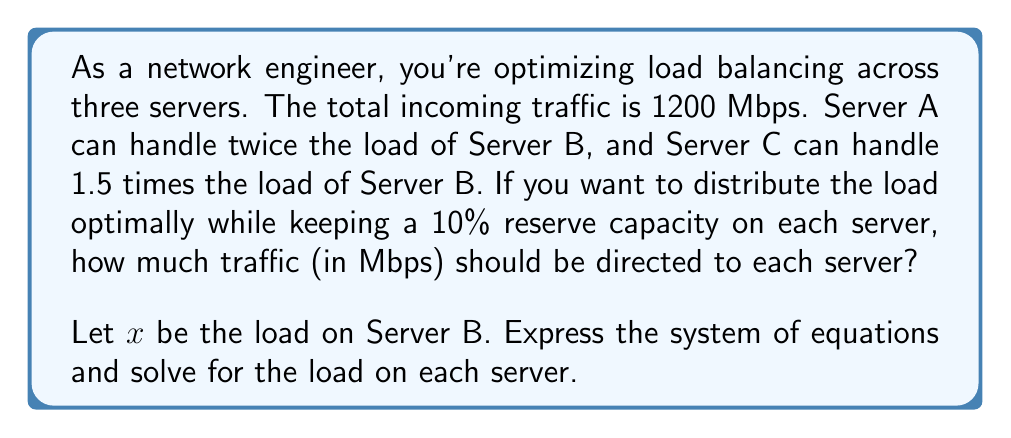Can you solve this math problem? Let's approach this step-by-step:

1) Let $x$ be the load on Server B. Then:
   - Load on Server A = $2x$
   - Load on Server C = $1.5x$

2) The total traffic is 1200 Mbps, so we can write our first equation:
   $$ x + 2x + 1.5x = 1200 $$

3) Simplify:
   $$ 4.5x = 1200 $$

4) Solve for $x$:
   $$ x = \frac{1200}{4.5} = 266.67 $$

5) Now, we know:
   - Server B load: $266.67$ Mbps
   - Server A load: $2 * 266.67 = 533.33$ Mbps
   - Server C load: $1.5 * 266.67 = 400$ Mbps

6) However, we need to keep a 10% reserve capacity on each server. To calculate the final loads:
   - Server A: $533.33 * 0.9 = 480$ Mbps
   - Server B: $266.67 * 0.9 = 240$ Mbps
   - Server C: $400 * 0.9 = 360$ Mbps

7) Verify: $480 + 240 + 360 = 1080$ Mbps, which is 90% of the total 1200 Mbps traffic (as expected with 10% reserve).
Answer: Server A: 480 Mbps
Server B: 240 Mbps
Server C: 360 Mbps 